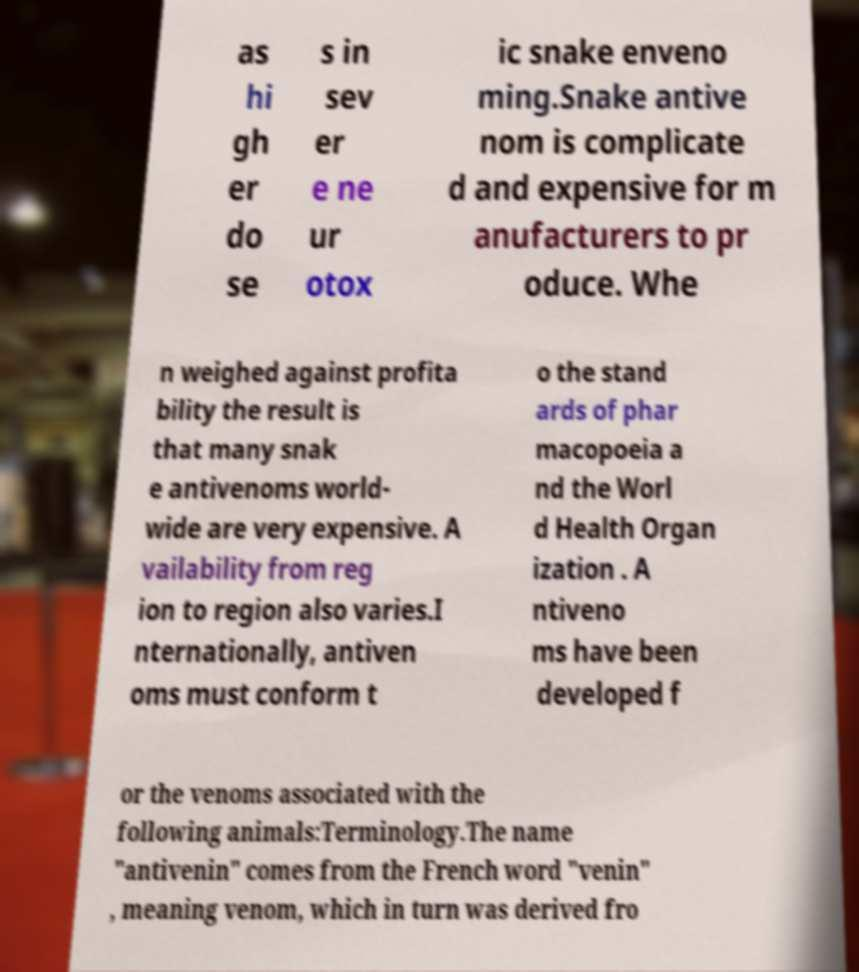Please read and relay the text visible in this image. What does it say? as hi gh er do se s in sev er e ne ur otox ic snake enveno ming.Snake antive nom is complicate d and expensive for m anufacturers to pr oduce. Whe n weighed against profita bility the result is that many snak e antivenoms world- wide are very expensive. A vailability from reg ion to region also varies.I nternationally, antiven oms must conform t o the stand ards of phar macopoeia a nd the Worl d Health Organ ization . A ntiveno ms have been developed f or the venoms associated with the following animals:Terminology.The name "antivenin" comes from the French word "venin" , meaning venom, which in turn was derived fro 